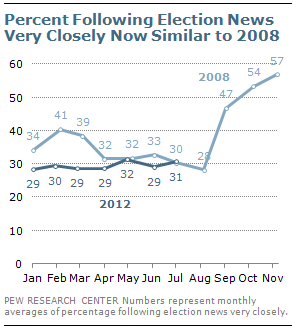Point out several critical features in this image. What is the total number of data points whose value is equal to 32 in the light blue line from 2 to ...? At what value did the light blue and navy blue lines merge? 